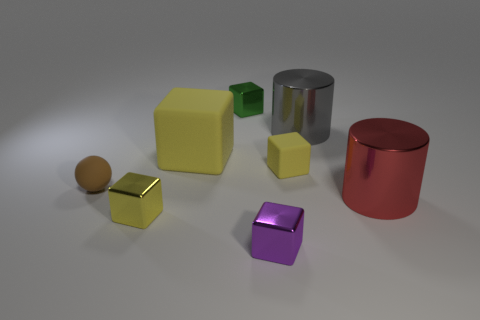Add 1 purple metal blocks. How many objects exist? 9 Subtract all tiny green cubes. How many cubes are left? 4 Subtract all yellow cylinders. How many yellow cubes are left? 3 Subtract all cylinders. How many objects are left? 6 Subtract all purple cubes. How many cubes are left? 4 Add 8 big yellow objects. How many big yellow objects exist? 9 Subtract 0 brown cylinders. How many objects are left? 8 Subtract all purple spheres. Subtract all green blocks. How many spheres are left? 1 Subtract all balls. Subtract all yellow metal things. How many objects are left? 6 Add 1 large yellow objects. How many large yellow objects are left? 2 